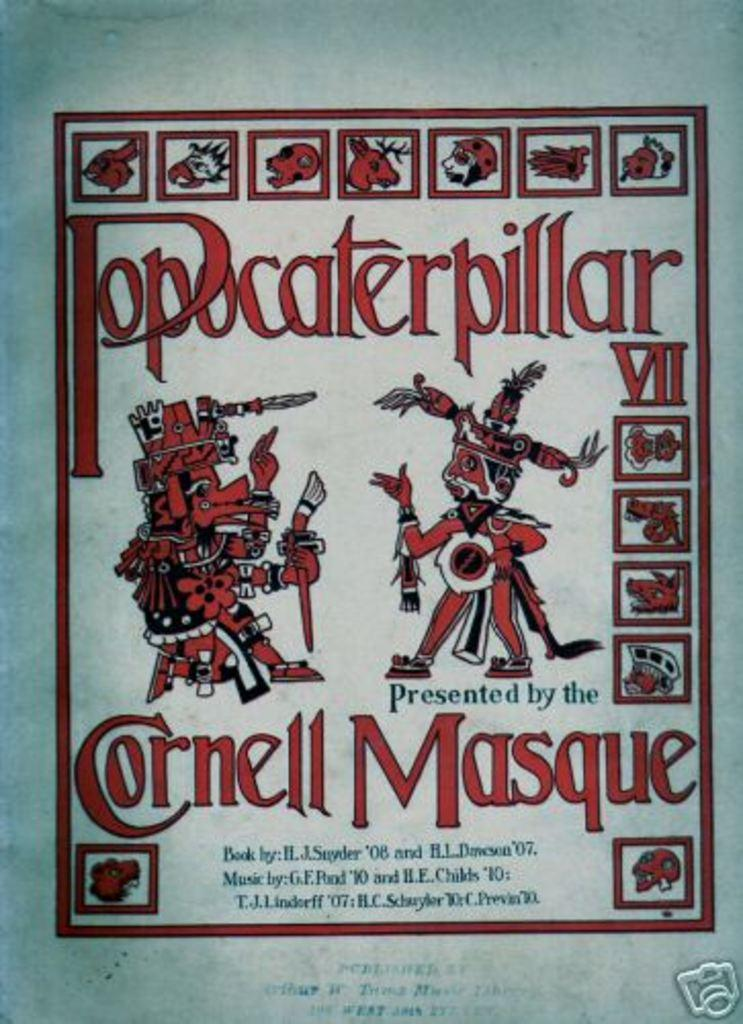<image>
Render a clear and concise summary of the photo. A poster of Popcaterpillar presented by Cornell Masque. 